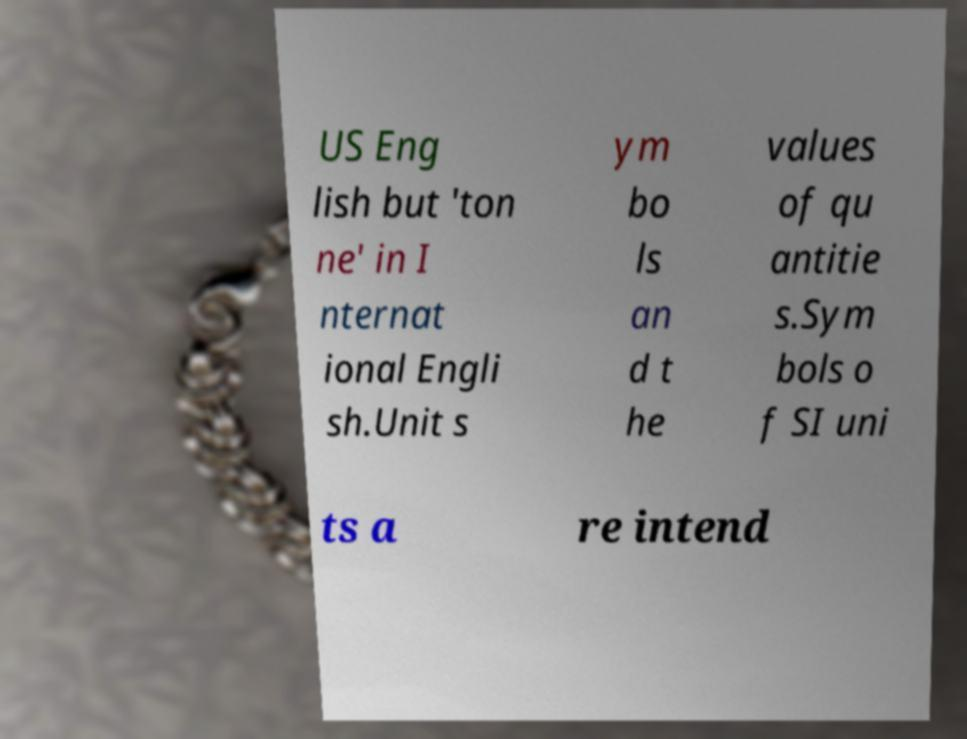For documentation purposes, I need the text within this image transcribed. Could you provide that? US Eng lish but 'ton ne' in I nternat ional Engli sh.Unit s ym bo ls an d t he values of qu antitie s.Sym bols o f SI uni ts a re intend 